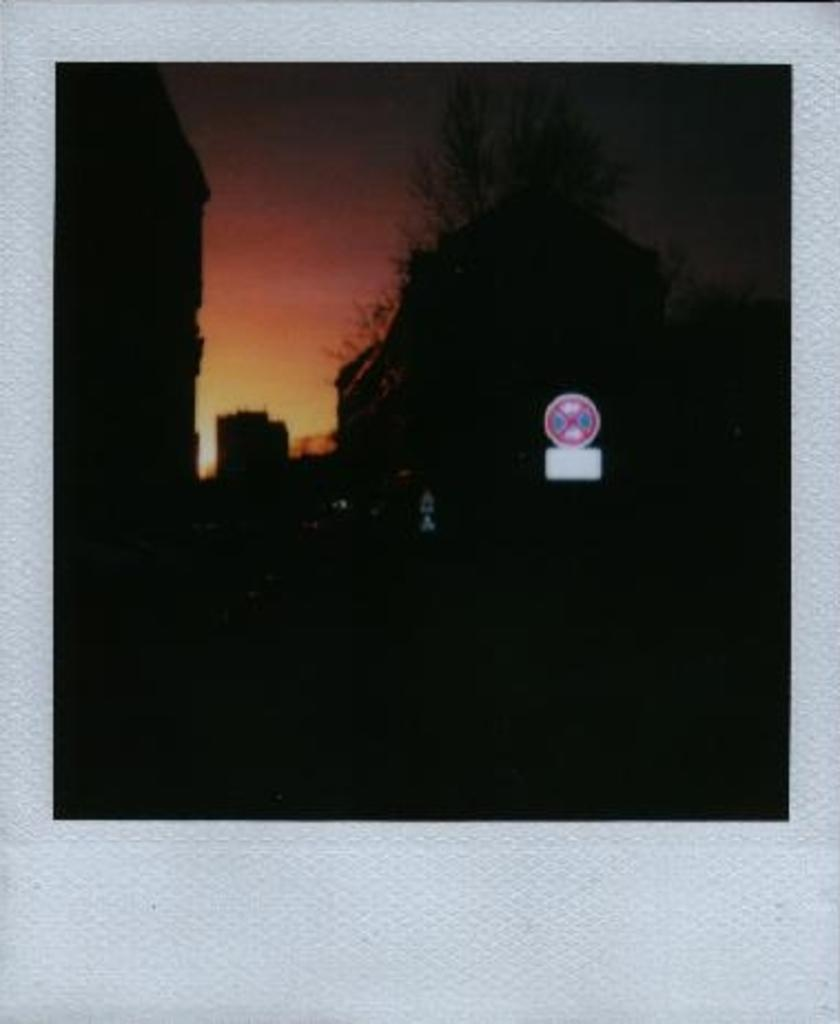What is the main subject of the image? There is a photograph in the image. What can be seen in the photograph? The photograph contains buildings, trees, and a sign board. What time does the clock in the photograph show? There is no clock present in the photograph. What is the aftermath of the event depicted in the photograph? There is no event depicted in the photograph, as it only contains buildings, trees, and a sign board. 